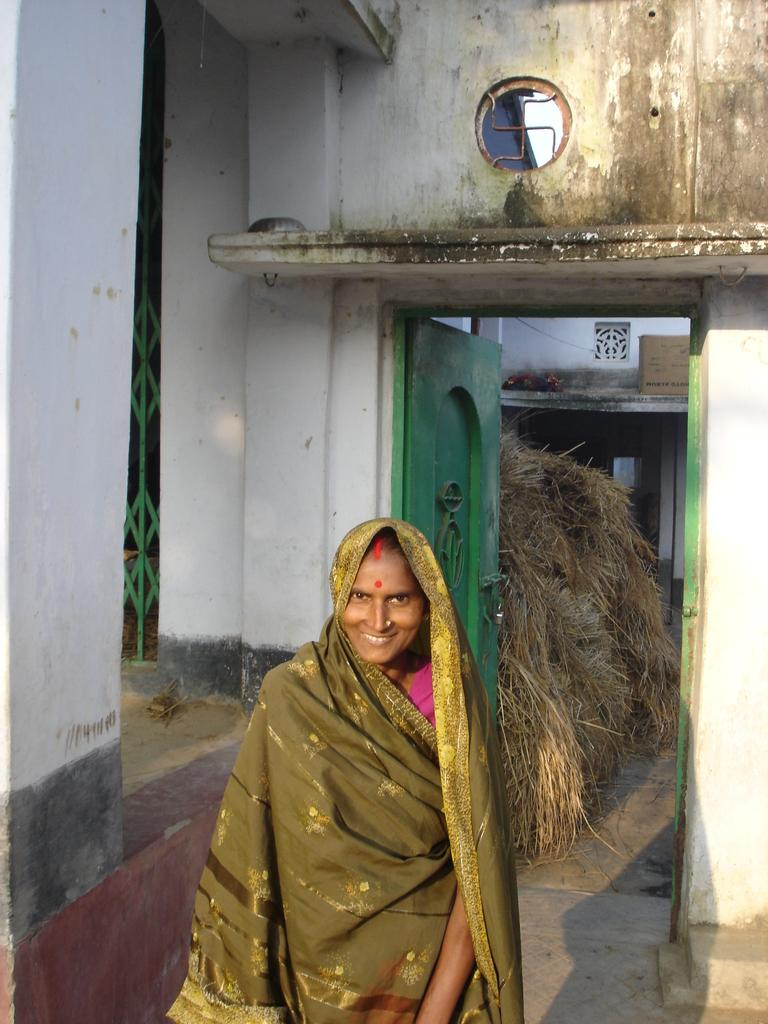Who is the main subject in the image? There is a woman in the image. Where is the woman standing? The woman is standing in front of a house. What can be seen on the house? There is a door and a box on the roof of the house. What is the surrounding area like? There is grass in the image, and there is a gate visible. What type of tin is the woman holding in the image? There is no tin present in the image; the woman is not holding anything. 